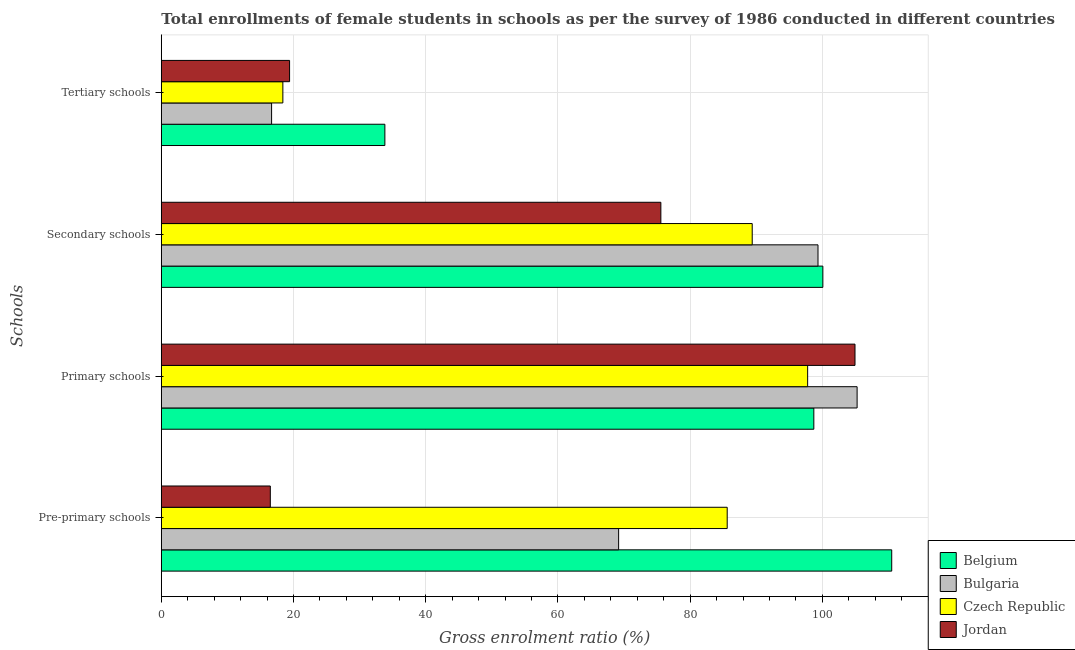How many different coloured bars are there?
Provide a succinct answer. 4. How many groups of bars are there?
Your answer should be compact. 4. Are the number of bars on each tick of the Y-axis equal?
Provide a short and direct response. Yes. How many bars are there on the 4th tick from the top?
Keep it short and to the point. 4. How many bars are there on the 2nd tick from the bottom?
Provide a short and direct response. 4. What is the label of the 1st group of bars from the top?
Offer a very short reply. Tertiary schools. What is the gross enrolment ratio(female) in primary schools in Czech Republic?
Make the answer very short. 97.78. Across all countries, what is the maximum gross enrolment ratio(female) in secondary schools?
Provide a succinct answer. 100.08. Across all countries, what is the minimum gross enrolment ratio(female) in tertiary schools?
Provide a succinct answer. 16.68. In which country was the gross enrolment ratio(female) in pre-primary schools maximum?
Your response must be concise. Belgium. What is the total gross enrolment ratio(female) in pre-primary schools in the graph?
Your answer should be very brief. 281.78. What is the difference between the gross enrolment ratio(female) in tertiary schools in Bulgaria and that in Belgium?
Offer a very short reply. -17.14. What is the difference between the gross enrolment ratio(female) in pre-primary schools in Jordan and the gross enrolment ratio(female) in primary schools in Bulgaria?
Offer a terse response. -88.77. What is the average gross enrolment ratio(female) in tertiary schools per country?
Your answer should be very brief. 22.07. What is the difference between the gross enrolment ratio(female) in pre-primary schools and gross enrolment ratio(female) in primary schools in Jordan?
Provide a succinct answer. -88.45. What is the ratio of the gross enrolment ratio(female) in primary schools in Czech Republic to that in Jordan?
Offer a very short reply. 0.93. What is the difference between the highest and the second highest gross enrolment ratio(female) in tertiary schools?
Provide a short and direct response. 14.42. What is the difference between the highest and the lowest gross enrolment ratio(female) in secondary schools?
Your answer should be compact. 24.51. Is the sum of the gross enrolment ratio(female) in primary schools in Belgium and Jordan greater than the maximum gross enrolment ratio(female) in tertiary schools across all countries?
Your answer should be compact. Yes. Is it the case that in every country, the sum of the gross enrolment ratio(female) in primary schools and gross enrolment ratio(female) in pre-primary schools is greater than the sum of gross enrolment ratio(female) in secondary schools and gross enrolment ratio(female) in tertiary schools?
Offer a very short reply. No. What does the 4th bar from the bottom in Secondary schools represents?
Offer a very short reply. Jordan. How many bars are there?
Your answer should be compact. 16. How many countries are there in the graph?
Offer a very short reply. 4. What is the difference between two consecutive major ticks on the X-axis?
Provide a succinct answer. 20. How are the legend labels stacked?
Your answer should be compact. Vertical. What is the title of the graph?
Your answer should be compact. Total enrollments of female students in schools as per the survey of 1986 conducted in different countries. What is the label or title of the X-axis?
Offer a very short reply. Gross enrolment ratio (%). What is the label or title of the Y-axis?
Offer a very short reply. Schools. What is the Gross enrolment ratio (%) in Belgium in Pre-primary schools?
Provide a succinct answer. 110.5. What is the Gross enrolment ratio (%) of Bulgaria in Pre-primary schools?
Make the answer very short. 69.18. What is the Gross enrolment ratio (%) of Czech Republic in Pre-primary schools?
Offer a terse response. 85.61. What is the Gross enrolment ratio (%) of Jordan in Pre-primary schools?
Provide a short and direct response. 16.49. What is the Gross enrolment ratio (%) in Belgium in Primary schools?
Keep it short and to the point. 98.71. What is the Gross enrolment ratio (%) of Bulgaria in Primary schools?
Offer a terse response. 105.26. What is the Gross enrolment ratio (%) in Czech Republic in Primary schools?
Your response must be concise. 97.78. What is the Gross enrolment ratio (%) of Jordan in Primary schools?
Your answer should be very brief. 104.94. What is the Gross enrolment ratio (%) of Belgium in Secondary schools?
Offer a very short reply. 100.08. What is the Gross enrolment ratio (%) in Bulgaria in Secondary schools?
Provide a short and direct response. 99.34. What is the Gross enrolment ratio (%) of Czech Republic in Secondary schools?
Offer a terse response. 89.39. What is the Gross enrolment ratio (%) of Jordan in Secondary schools?
Your answer should be very brief. 75.57. What is the Gross enrolment ratio (%) in Belgium in Tertiary schools?
Give a very brief answer. 33.82. What is the Gross enrolment ratio (%) of Bulgaria in Tertiary schools?
Provide a succinct answer. 16.68. What is the Gross enrolment ratio (%) in Czech Republic in Tertiary schools?
Give a very brief answer. 18.39. What is the Gross enrolment ratio (%) of Jordan in Tertiary schools?
Offer a terse response. 19.4. Across all Schools, what is the maximum Gross enrolment ratio (%) in Belgium?
Your answer should be very brief. 110.5. Across all Schools, what is the maximum Gross enrolment ratio (%) in Bulgaria?
Your answer should be very brief. 105.26. Across all Schools, what is the maximum Gross enrolment ratio (%) in Czech Republic?
Your response must be concise. 97.78. Across all Schools, what is the maximum Gross enrolment ratio (%) of Jordan?
Offer a terse response. 104.94. Across all Schools, what is the minimum Gross enrolment ratio (%) in Belgium?
Your answer should be compact. 33.82. Across all Schools, what is the minimum Gross enrolment ratio (%) in Bulgaria?
Make the answer very short. 16.68. Across all Schools, what is the minimum Gross enrolment ratio (%) of Czech Republic?
Your answer should be compact. 18.39. Across all Schools, what is the minimum Gross enrolment ratio (%) in Jordan?
Offer a very short reply. 16.49. What is the total Gross enrolment ratio (%) in Belgium in the graph?
Offer a terse response. 343.11. What is the total Gross enrolment ratio (%) of Bulgaria in the graph?
Give a very brief answer. 290.47. What is the total Gross enrolment ratio (%) of Czech Republic in the graph?
Offer a terse response. 291.17. What is the total Gross enrolment ratio (%) in Jordan in the graph?
Your response must be concise. 216.41. What is the difference between the Gross enrolment ratio (%) in Belgium in Pre-primary schools and that in Primary schools?
Your answer should be compact. 11.78. What is the difference between the Gross enrolment ratio (%) in Bulgaria in Pre-primary schools and that in Primary schools?
Your response must be concise. -36.08. What is the difference between the Gross enrolment ratio (%) in Czech Republic in Pre-primary schools and that in Primary schools?
Your answer should be compact. -12.17. What is the difference between the Gross enrolment ratio (%) in Jordan in Pre-primary schools and that in Primary schools?
Keep it short and to the point. -88.45. What is the difference between the Gross enrolment ratio (%) of Belgium in Pre-primary schools and that in Secondary schools?
Provide a succinct answer. 10.42. What is the difference between the Gross enrolment ratio (%) in Bulgaria in Pre-primary schools and that in Secondary schools?
Provide a short and direct response. -30.16. What is the difference between the Gross enrolment ratio (%) in Czech Republic in Pre-primary schools and that in Secondary schools?
Make the answer very short. -3.78. What is the difference between the Gross enrolment ratio (%) in Jordan in Pre-primary schools and that in Secondary schools?
Provide a short and direct response. -59.08. What is the difference between the Gross enrolment ratio (%) in Belgium in Pre-primary schools and that in Tertiary schools?
Provide a succinct answer. 76.68. What is the difference between the Gross enrolment ratio (%) in Bulgaria in Pre-primary schools and that in Tertiary schools?
Make the answer very short. 52.5. What is the difference between the Gross enrolment ratio (%) of Czech Republic in Pre-primary schools and that in Tertiary schools?
Offer a terse response. 67.22. What is the difference between the Gross enrolment ratio (%) of Jordan in Pre-primary schools and that in Tertiary schools?
Your answer should be very brief. -2.91. What is the difference between the Gross enrolment ratio (%) of Belgium in Primary schools and that in Secondary schools?
Your answer should be compact. -1.37. What is the difference between the Gross enrolment ratio (%) in Bulgaria in Primary schools and that in Secondary schools?
Provide a succinct answer. 5.92. What is the difference between the Gross enrolment ratio (%) of Czech Republic in Primary schools and that in Secondary schools?
Provide a short and direct response. 8.39. What is the difference between the Gross enrolment ratio (%) in Jordan in Primary schools and that in Secondary schools?
Provide a short and direct response. 29.37. What is the difference between the Gross enrolment ratio (%) of Belgium in Primary schools and that in Tertiary schools?
Offer a very short reply. 64.89. What is the difference between the Gross enrolment ratio (%) in Bulgaria in Primary schools and that in Tertiary schools?
Offer a terse response. 88.58. What is the difference between the Gross enrolment ratio (%) in Czech Republic in Primary schools and that in Tertiary schools?
Provide a succinct answer. 79.39. What is the difference between the Gross enrolment ratio (%) in Jordan in Primary schools and that in Tertiary schools?
Your answer should be compact. 85.54. What is the difference between the Gross enrolment ratio (%) of Belgium in Secondary schools and that in Tertiary schools?
Ensure brevity in your answer.  66.26. What is the difference between the Gross enrolment ratio (%) of Bulgaria in Secondary schools and that in Tertiary schools?
Provide a succinct answer. 82.66. What is the difference between the Gross enrolment ratio (%) of Czech Republic in Secondary schools and that in Tertiary schools?
Your response must be concise. 71. What is the difference between the Gross enrolment ratio (%) in Jordan in Secondary schools and that in Tertiary schools?
Provide a short and direct response. 56.17. What is the difference between the Gross enrolment ratio (%) in Belgium in Pre-primary schools and the Gross enrolment ratio (%) in Bulgaria in Primary schools?
Make the answer very short. 5.24. What is the difference between the Gross enrolment ratio (%) of Belgium in Pre-primary schools and the Gross enrolment ratio (%) of Czech Republic in Primary schools?
Provide a succinct answer. 12.72. What is the difference between the Gross enrolment ratio (%) of Belgium in Pre-primary schools and the Gross enrolment ratio (%) of Jordan in Primary schools?
Keep it short and to the point. 5.55. What is the difference between the Gross enrolment ratio (%) of Bulgaria in Pre-primary schools and the Gross enrolment ratio (%) of Czech Republic in Primary schools?
Your response must be concise. -28.6. What is the difference between the Gross enrolment ratio (%) in Bulgaria in Pre-primary schools and the Gross enrolment ratio (%) in Jordan in Primary schools?
Your answer should be very brief. -35.76. What is the difference between the Gross enrolment ratio (%) in Czech Republic in Pre-primary schools and the Gross enrolment ratio (%) in Jordan in Primary schools?
Ensure brevity in your answer.  -19.33. What is the difference between the Gross enrolment ratio (%) of Belgium in Pre-primary schools and the Gross enrolment ratio (%) of Bulgaria in Secondary schools?
Your answer should be very brief. 11.15. What is the difference between the Gross enrolment ratio (%) of Belgium in Pre-primary schools and the Gross enrolment ratio (%) of Czech Republic in Secondary schools?
Provide a short and direct response. 21.11. What is the difference between the Gross enrolment ratio (%) in Belgium in Pre-primary schools and the Gross enrolment ratio (%) in Jordan in Secondary schools?
Provide a succinct answer. 34.93. What is the difference between the Gross enrolment ratio (%) of Bulgaria in Pre-primary schools and the Gross enrolment ratio (%) of Czech Republic in Secondary schools?
Ensure brevity in your answer.  -20.21. What is the difference between the Gross enrolment ratio (%) in Bulgaria in Pre-primary schools and the Gross enrolment ratio (%) in Jordan in Secondary schools?
Provide a succinct answer. -6.39. What is the difference between the Gross enrolment ratio (%) in Czech Republic in Pre-primary schools and the Gross enrolment ratio (%) in Jordan in Secondary schools?
Offer a terse response. 10.04. What is the difference between the Gross enrolment ratio (%) of Belgium in Pre-primary schools and the Gross enrolment ratio (%) of Bulgaria in Tertiary schools?
Your response must be concise. 93.81. What is the difference between the Gross enrolment ratio (%) in Belgium in Pre-primary schools and the Gross enrolment ratio (%) in Czech Republic in Tertiary schools?
Ensure brevity in your answer.  92.11. What is the difference between the Gross enrolment ratio (%) in Belgium in Pre-primary schools and the Gross enrolment ratio (%) in Jordan in Tertiary schools?
Provide a short and direct response. 91.09. What is the difference between the Gross enrolment ratio (%) of Bulgaria in Pre-primary schools and the Gross enrolment ratio (%) of Czech Republic in Tertiary schools?
Keep it short and to the point. 50.8. What is the difference between the Gross enrolment ratio (%) in Bulgaria in Pre-primary schools and the Gross enrolment ratio (%) in Jordan in Tertiary schools?
Give a very brief answer. 49.78. What is the difference between the Gross enrolment ratio (%) in Czech Republic in Pre-primary schools and the Gross enrolment ratio (%) in Jordan in Tertiary schools?
Your answer should be compact. 66.21. What is the difference between the Gross enrolment ratio (%) in Belgium in Primary schools and the Gross enrolment ratio (%) in Bulgaria in Secondary schools?
Offer a terse response. -0.63. What is the difference between the Gross enrolment ratio (%) of Belgium in Primary schools and the Gross enrolment ratio (%) of Czech Republic in Secondary schools?
Your answer should be compact. 9.32. What is the difference between the Gross enrolment ratio (%) in Belgium in Primary schools and the Gross enrolment ratio (%) in Jordan in Secondary schools?
Give a very brief answer. 23.14. What is the difference between the Gross enrolment ratio (%) in Bulgaria in Primary schools and the Gross enrolment ratio (%) in Czech Republic in Secondary schools?
Offer a terse response. 15.87. What is the difference between the Gross enrolment ratio (%) in Bulgaria in Primary schools and the Gross enrolment ratio (%) in Jordan in Secondary schools?
Your answer should be compact. 29.69. What is the difference between the Gross enrolment ratio (%) of Czech Republic in Primary schools and the Gross enrolment ratio (%) of Jordan in Secondary schools?
Offer a terse response. 22.21. What is the difference between the Gross enrolment ratio (%) in Belgium in Primary schools and the Gross enrolment ratio (%) in Bulgaria in Tertiary schools?
Ensure brevity in your answer.  82.03. What is the difference between the Gross enrolment ratio (%) in Belgium in Primary schools and the Gross enrolment ratio (%) in Czech Republic in Tertiary schools?
Your response must be concise. 80.33. What is the difference between the Gross enrolment ratio (%) of Belgium in Primary schools and the Gross enrolment ratio (%) of Jordan in Tertiary schools?
Your answer should be very brief. 79.31. What is the difference between the Gross enrolment ratio (%) in Bulgaria in Primary schools and the Gross enrolment ratio (%) in Czech Republic in Tertiary schools?
Ensure brevity in your answer.  86.87. What is the difference between the Gross enrolment ratio (%) of Bulgaria in Primary schools and the Gross enrolment ratio (%) of Jordan in Tertiary schools?
Keep it short and to the point. 85.86. What is the difference between the Gross enrolment ratio (%) of Czech Republic in Primary schools and the Gross enrolment ratio (%) of Jordan in Tertiary schools?
Provide a succinct answer. 78.38. What is the difference between the Gross enrolment ratio (%) in Belgium in Secondary schools and the Gross enrolment ratio (%) in Bulgaria in Tertiary schools?
Offer a very short reply. 83.4. What is the difference between the Gross enrolment ratio (%) of Belgium in Secondary schools and the Gross enrolment ratio (%) of Czech Republic in Tertiary schools?
Give a very brief answer. 81.69. What is the difference between the Gross enrolment ratio (%) of Belgium in Secondary schools and the Gross enrolment ratio (%) of Jordan in Tertiary schools?
Ensure brevity in your answer.  80.68. What is the difference between the Gross enrolment ratio (%) in Bulgaria in Secondary schools and the Gross enrolment ratio (%) in Czech Republic in Tertiary schools?
Ensure brevity in your answer.  80.96. What is the difference between the Gross enrolment ratio (%) in Bulgaria in Secondary schools and the Gross enrolment ratio (%) in Jordan in Tertiary schools?
Offer a terse response. 79.94. What is the difference between the Gross enrolment ratio (%) of Czech Republic in Secondary schools and the Gross enrolment ratio (%) of Jordan in Tertiary schools?
Ensure brevity in your answer.  69.99. What is the average Gross enrolment ratio (%) in Belgium per Schools?
Your response must be concise. 85.78. What is the average Gross enrolment ratio (%) of Bulgaria per Schools?
Make the answer very short. 72.62. What is the average Gross enrolment ratio (%) of Czech Republic per Schools?
Provide a short and direct response. 72.79. What is the average Gross enrolment ratio (%) of Jordan per Schools?
Your answer should be very brief. 54.1. What is the difference between the Gross enrolment ratio (%) in Belgium and Gross enrolment ratio (%) in Bulgaria in Pre-primary schools?
Your answer should be very brief. 41.31. What is the difference between the Gross enrolment ratio (%) in Belgium and Gross enrolment ratio (%) in Czech Republic in Pre-primary schools?
Provide a succinct answer. 24.89. What is the difference between the Gross enrolment ratio (%) of Belgium and Gross enrolment ratio (%) of Jordan in Pre-primary schools?
Provide a succinct answer. 94.01. What is the difference between the Gross enrolment ratio (%) of Bulgaria and Gross enrolment ratio (%) of Czech Republic in Pre-primary schools?
Keep it short and to the point. -16.43. What is the difference between the Gross enrolment ratio (%) of Bulgaria and Gross enrolment ratio (%) of Jordan in Pre-primary schools?
Provide a succinct answer. 52.69. What is the difference between the Gross enrolment ratio (%) in Czech Republic and Gross enrolment ratio (%) in Jordan in Pre-primary schools?
Your response must be concise. 69.12. What is the difference between the Gross enrolment ratio (%) in Belgium and Gross enrolment ratio (%) in Bulgaria in Primary schools?
Give a very brief answer. -6.55. What is the difference between the Gross enrolment ratio (%) in Belgium and Gross enrolment ratio (%) in Czech Republic in Primary schools?
Provide a succinct answer. 0.94. What is the difference between the Gross enrolment ratio (%) in Belgium and Gross enrolment ratio (%) in Jordan in Primary schools?
Offer a terse response. -6.23. What is the difference between the Gross enrolment ratio (%) of Bulgaria and Gross enrolment ratio (%) of Czech Republic in Primary schools?
Provide a short and direct response. 7.48. What is the difference between the Gross enrolment ratio (%) in Bulgaria and Gross enrolment ratio (%) in Jordan in Primary schools?
Make the answer very short. 0.32. What is the difference between the Gross enrolment ratio (%) in Czech Republic and Gross enrolment ratio (%) in Jordan in Primary schools?
Your answer should be compact. -7.16. What is the difference between the Gross enrolment ratio (%) in Belgium and Gross enrolment ratio (%) in Bulgaria in Secondary schools?
Make the answer very short. 0.73. What is the difference between the Gross enrolment ratio (%) in Belgium and Gross enrolment ratio (%) in Czech Republic in Secondary schools?
Your answer should be very brief. 10.69. What is the difference between the Gross enrolment ratio (%) in Belgium and Gross enrolment ratio (%) in Jordan in Secondary schools?
Your answer should be very brief. 24.51. What is the difference between the Gross enrolment ratio (%) in Bulgaria and Gross enrolment ratio (%) in Czech Republic in Secondary schools?
Keep it short and to the point. 9.95. What is the difference between the Gross enrolment ratio (%) in Bulgaria and Gross enrolment ratio (%) in Jordan in Secondary schools?
Give a very brief answer. 23.77. What is the difference between the Gross enrolment ratio (%) in Czech Republic and Gross enrolment ratio (%) in Jordan in Secondary schools?
Offer a terse response. 13.82. What is the difference between the Gross enrolment ratio (%) of Belgium and Gross enrolment ratio (%) of Bulgaria in Tertiary schools?
Your answer should be very brief. 17.14. What is the difference between the Gross enrolment ratio (%) in Belgium and Gross enrolment ratio (%) in Czech Republic in Tertiary schools?
Offer a terse response. 15.43. What is the difference between the Gross enrolment ratio (%) in Belgium and Gross enrolment ratio (%) in Jordan in Tertiary schools?
Offer a very short reply. 14.42. What is the difference between the Gross enrolment ratio (%) of Bulgaria and Gross enrolment ratio (%) of Czech Republic in Tertiary schools?
Keep it short and to the point. -1.71. What is the difference between the Gross enrolment ratio (%) of Bulgaria and Gross enrolment ratio (%) of Jordan in Tertiary schools?
Your answer should be compact. -2.72. What is the difference between the Gross enrolment ratio (%) of Czech Republic and Gross enrolment ratio (%) of Jordan in Tertiary schools?
Make the answer very short. -1.01. What is the ratio of the Gross enrolment ratio (%) in Belgium in Pre-primary schools to that in Primary schools?
Your response must be concise. 1.12. What is the ratio of the Gross enrolment ratio (%) of Bulgaria in Pre-primary schools to that in Primary schools?
Your answer should be compact. 0.66. What is the ratio of the Gross enrolment ratio (%) in Czech Republic in Pre-primary schools to that in Primary schools?
Offer a very short reply. 0.88. What is the ratio of the Gross enrolment ratio (%) in Jordan in Pre-primary schools to that in Primary schools?
Make the answer very short. 0.16. What is the ratio of the Gross enrolment ratio (%) of Belgium in Pre-primary schools to that in Secondary schools?
Your response must be concise. 1.1. What is the ratio of the Gross enrolment ratio (%) in Bulgaria in Pre-primary schools to that in Secondary schools?
Provide a succinct answer. 0.7. What is the ratio of the Gross enrolment ratio (%) of Czech Republic in Pre-primary schools to that in Secondary schools?
Provide a succinct answer. 0.96. What is the ratio of the Gross enrolment ratio (%) of Jordan in Pre-primary schools to that in Secondary schools?
Ensure brevity in your answer.  0.22. What is the ratio of the Gross enrolment ratio (%) in Belgium in Pre-primary schools to that in Tertiary schools?
Provide a short and direct response. 3.27. What is the ratio of the Gross enrolment ratio (%) of Bulgaria in Pre-primary schools to that in Tertiary schools?
Offer a very short reply. 4.15. What is the ratio of the Gross enrolment ratio (%) of Czech Republic in Pre-primary schools to that in Tertiary schools?
Your response must be concise. 4.66. What is the ratio of the Gross enrolment ratio (%) of Jordan in Pre-primary schools to that in Tertiary schools?
Your answer should be compact. 0.85. What is the ratio of the Gross enrolment ratio (%) of Belgium in Primary schools to that in Secondary schools?
Offer a terse response. 0.99. What is the ratio of the Gross enrolment ratio (%) of Bulgaria in Primary schools to that in Secondary schools?
Offer a very short reply. 1.06. What is the ratio of the Gross enrolment ratio (%) in Czech Republic in Primary schools to that in Secondary schools?
Your answer should be compact. 1.09. What is the ratio of the Gross enrolment ratio (%) of Jordan in Primary schools to that in Secondary schools?
Provide a succinct answer. 1.39. What is the ratio of the Gross enrolment ratio (%) of Belgium in Primary schools to that in Tertiary schools?
Ensure brevity in your answer.  2.92. What is the ratio of the Gross enrolment ratio (%) of Bulgaria in Primary schools to that in Tertiary schools?
Ensure brevity in your answer.  6.31. What is the ratio of the Gross enrolment ratio (%) in Czech Republic in Primary schools to that in Tertiary schools?
Provide a succinct answer. 5.32. What is the ratio of the Gross enrolment ratio (%) in Jordan in Primary schools to that in Tertiary schools?
Your answer should be very brief. 5.41. What is the ratio of the Gross enrolment ratio (%) in Belgium in Secondary schools to that in Tertiary schools?
Keep it short and to the point. 2.96. What is the ratio of the Gross enrolment ratio (%) of Bulgaria in Secondary schools to that in Tertiary schools?
Make the answer very short. 5.96. What is the ratio of the Gross enrolment ratio (%) in Czech Republic in Secondary schools to that in Tertiary schools?
Make the answer very short. 4.86. What is the ratio of the Gross enrolment ratio (%) in Jordan in Secondary schools to that in Tertiary schools?
Your response must be concise. 3.89. What is the difference between the highest and the second highest Gross enrolment ratio (%) of Belgium?
Offer a terse response. 10.42. What is the difference between the highest and the second highest Gross enrolment ratio (%) in Bulgaria?
Make the answer very short. 5.92. What is the difference between the highest and the second highest Gross enrolment ratio (%) of Czech Republic?
Offer a very short reply. 8.39. What is the difference between the highest and the second highest Gross enrolment ratio (%) of Jordan?
Ensure brevity in your answer.  29.37. What is the difference between the highest and the lowest Gross enrolment ratio (%) in Belgium?
Make the answer very short. 76.68. What is the difference between the highest and the lowest Gross enrolment ratio (%) in Bulgaria?
Offer a very short reply. 88.58. What is the difference between the highest and the lowest Gross enrolment ratio (%) of Czech Republic?
Ensure brevity in your answer.  79.39. What is the difference between the highest and the lowest Gross enrolment ratio (%) in Jordan?
Your response must be concise. 88.45. 